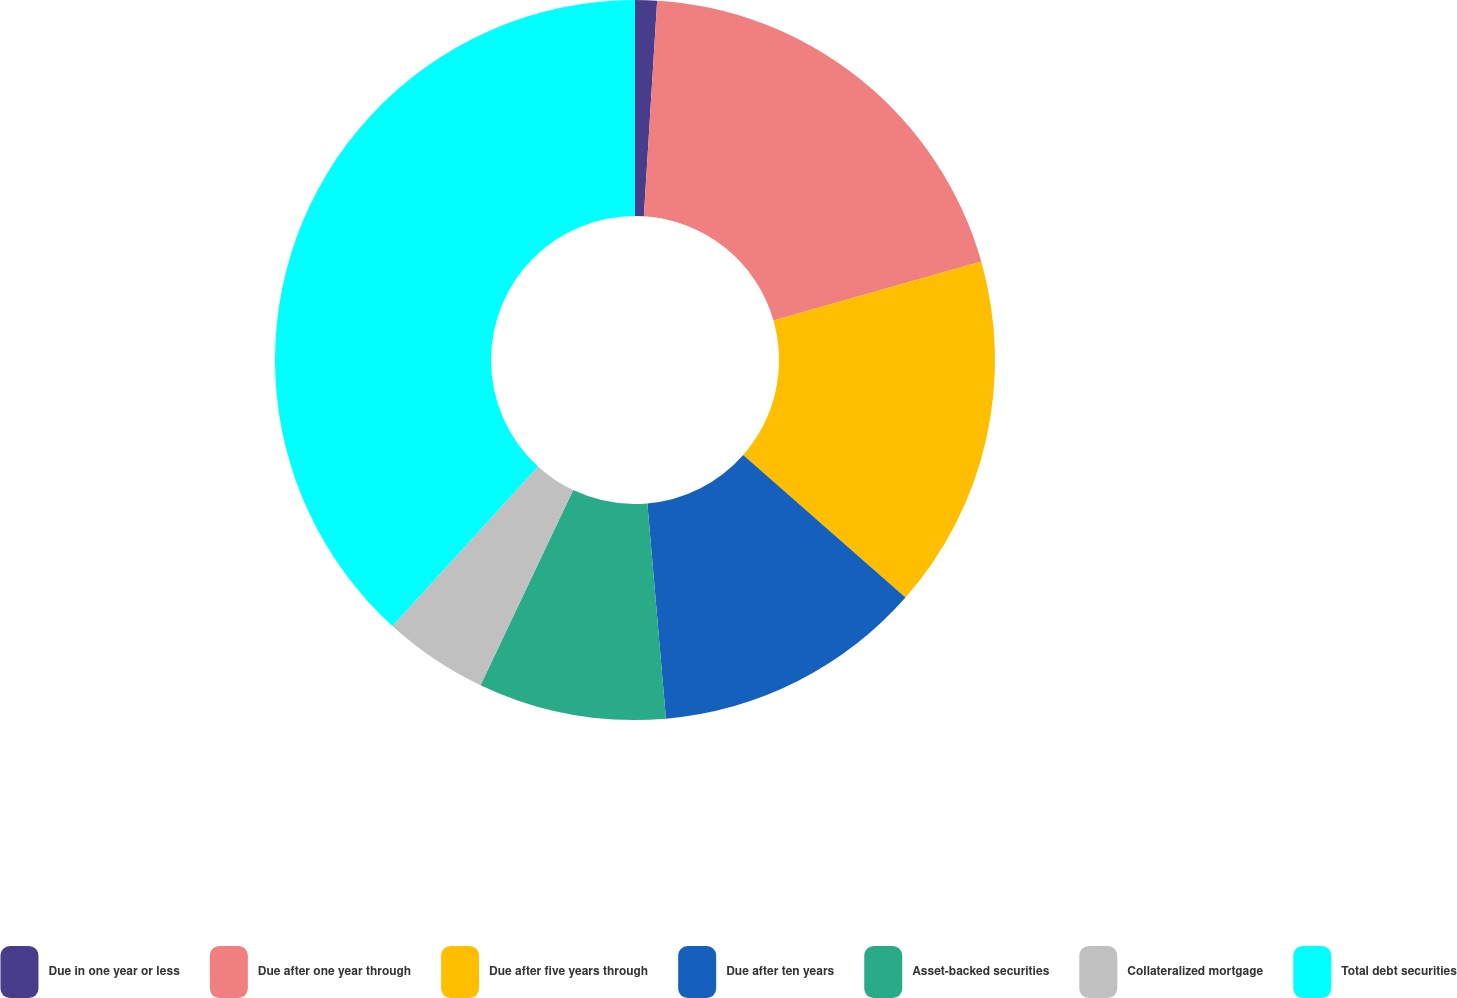<chart> <loc_0><loc_0><loc_500><loc_500><pie_chart><fcel>Due in one year or less<fcel>Due after one year through<fcel>Due after five years through<fcel>Due after ten years<fcel>Asset-backed securities<fcel>Collateralized mortgage<fcel>Total debt securities<nl><fcel>0.98%<fcel>19.61%<fcel>15.88%<fcel>12.16%<fcel>8.43%<fcel>4.71%<fcel>38.23%<nl></chart> 